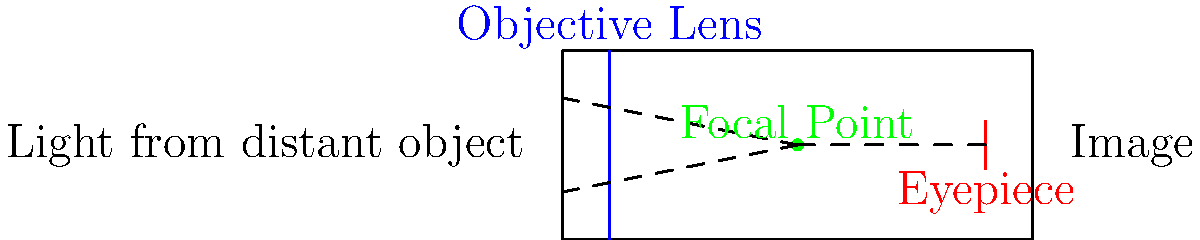As a parent who often encourages your child's curiosity about the night sky, explain how the main parts of a refracting telescope work together to form an image. Refer to the labeled diagram and describe the path of light through the telescope. To explain how a refracting telescope works to your child, follow these steps:

1. Light entry: Light from distant objects enters the telescope through the objective lens (blue line in the diagram).

2. Objective lens: This large lens at the front of the telescope collects and focuses the incoming light. It bends (refracts) the light rays towards a common point.

3. Focal point: The light rays converge at the focal point (green dot in the diagram). This is where a clear image of the distant object is formed, but it's too small to see clearly with the naked eye.

4. Eyepiece: The small lens near the observer's eye (red line in the diagram) acts like a magnifying glass. It takes the small image formed at the focal point and enlarges it.

5. Image formation: The eyepiece creates a larger, virtual image that appears to be farther away and much bigger than the original object.

6. Observation: When you look through the eyepiece, you see this magnified image of the distant object.

The telescope's tube keeps these components aligned properly and blocks out stray light that could interfere with the image.
Answer: Light enters objective lens, focuses at focal point, eyepiece magnifies image for viewing. 